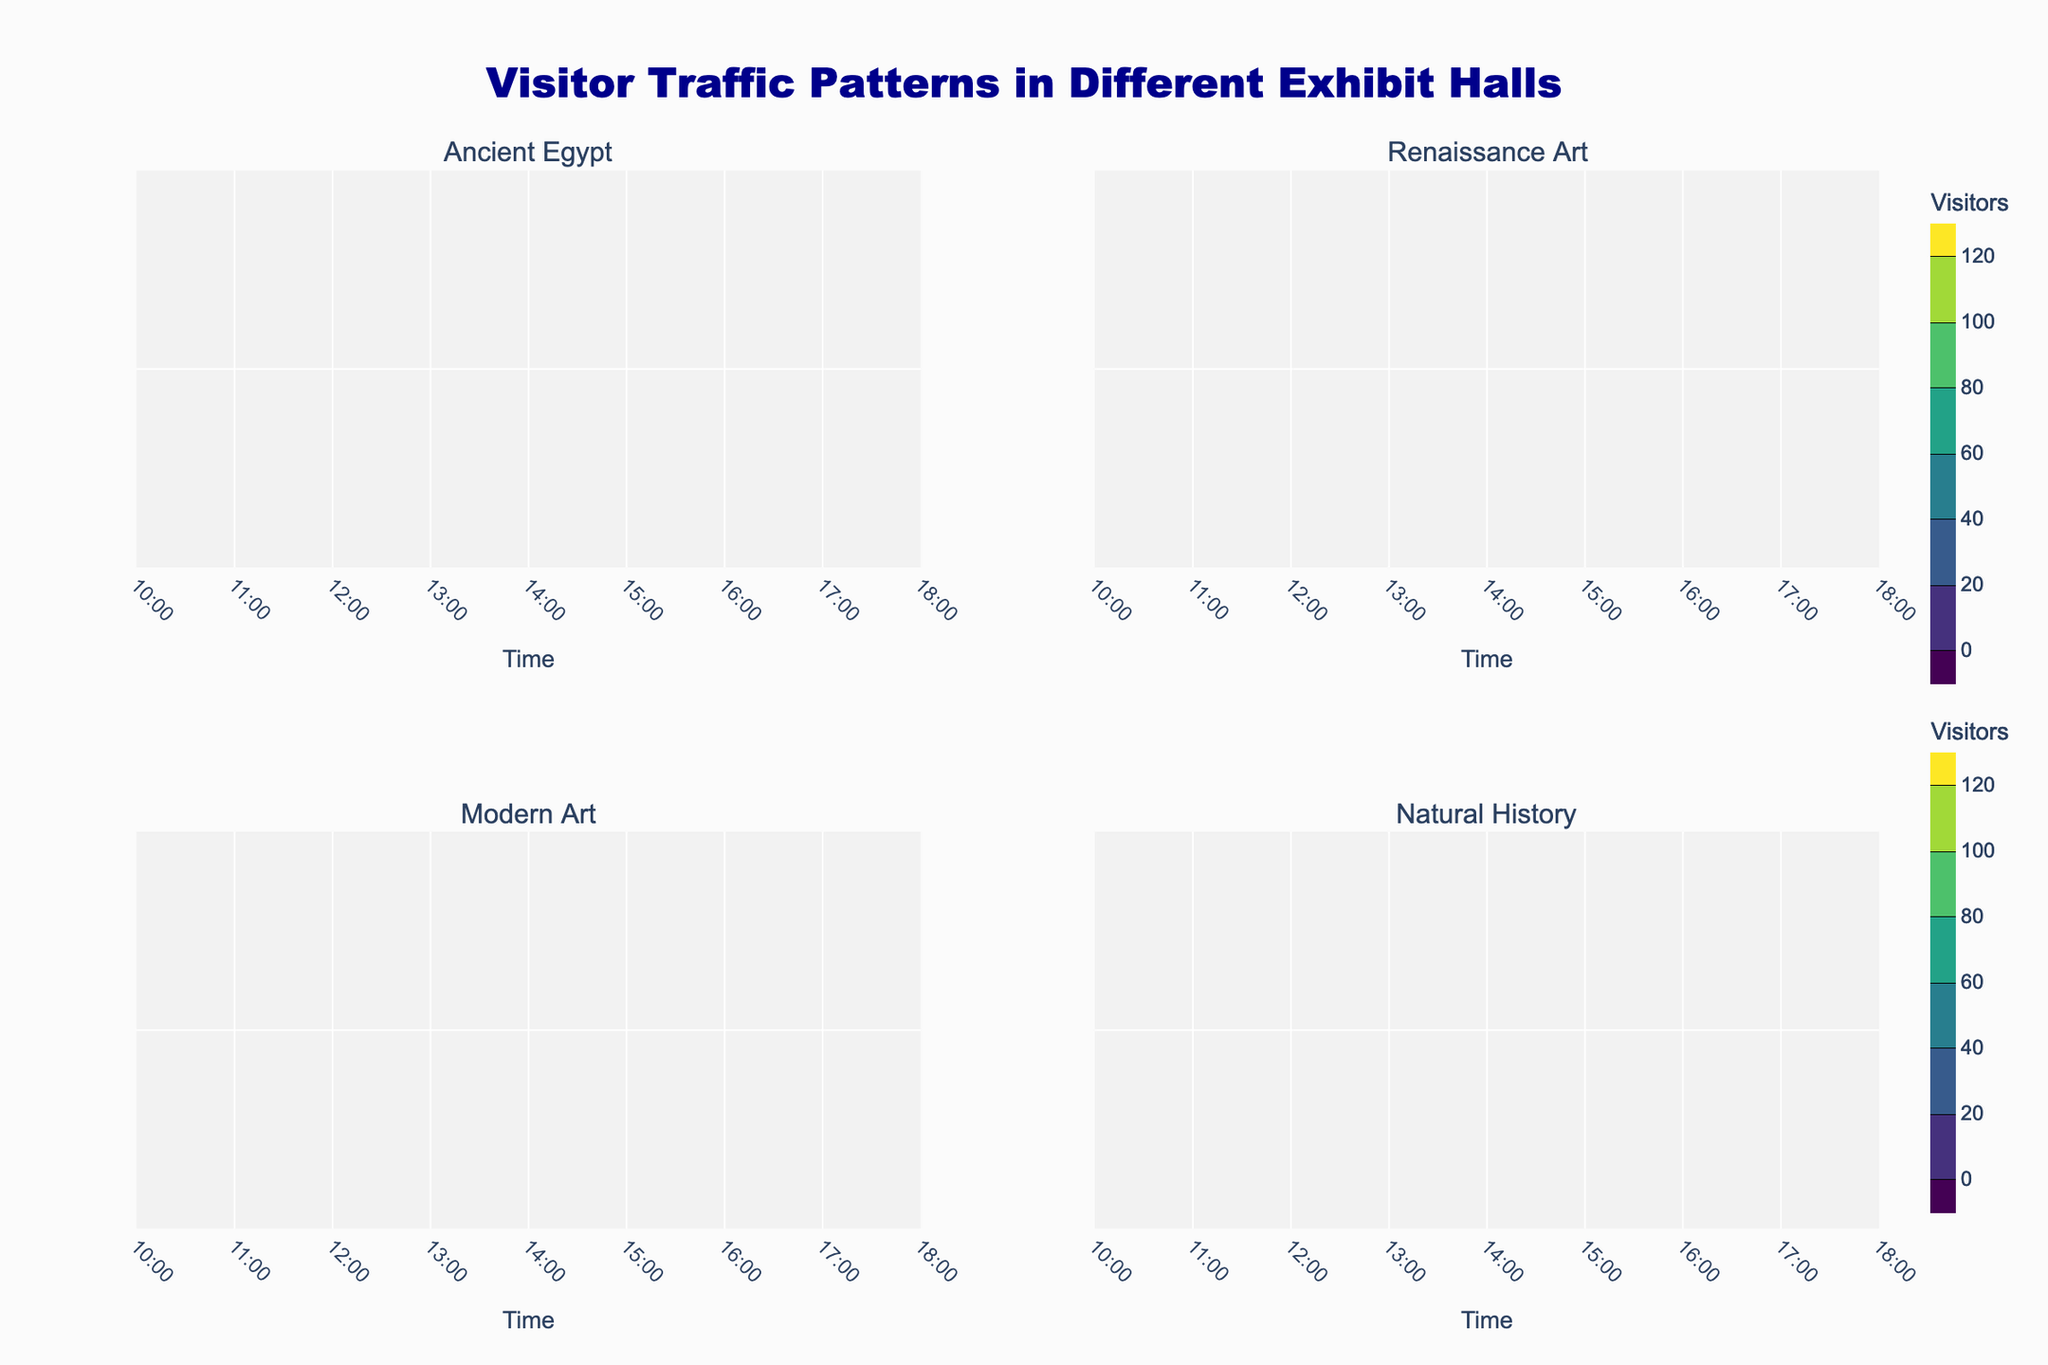What is the title of the figure? The title is displayed prominently at the top of the figure, and it reads "Visitor Traffic Patterns in Different Exhibit Halls."
Answer: Visitor Traffic Patterns in Different Exhibit Halls Which exhibit hall has the highest peak visitor count? By observing the color intensity and the contour levels in each subplot, the Natural History hall shows the highest peak visitor count with 130 visitors around 15:00.
Answer: Natural History hall At what time does the Modern Art hall see the maximum number of visitors? In the subplot for the Modern Art hall, the deepest color intensity and the highest contour label indicate the maximum number of visitors at 16:00 with 120 visitors.
Answer: 16:00 Compare the visitor traffic between 12:00 and 14:00 in the Renaissance Art and Ancient Egypt halls. Which hall experiences a larger increase in visitors? For Renaissance Art, visitors increase from 45 to 75. In Ancient Egypt, they increase from 70 to 90. Renaissance Art sees an increase of 30 visitors, while Ancient Egypt sees an increase of 20 visitors.
Answer: Renaissance Art Identify any time period where visitor traffic is similar across all halls. What time is it? Observe the contour lines and color shades across all subplots, and note if any contours coincide or have similar values regardless of the hall. Around 10:00, the visitor numbers range from 15 to 30, showing the most similarity across all halls.
Answer: 10:00 Determine which hall has the largest variation in visitor traffic throughout the day. Variation in visitor traffic can be assessed by comparing the lowest and highest contour levels in each subplot. The Natural History hall has the largest variation, with visitor counts ranging from 15 to 130.
Answer: Natural History hall How does visitor traffic at 17:00 compare between Modern Art and Renaissance Art halls? The subplot for Modern Art shows 85 visitors at 17:00, while the Renaissance Art hall has 65. Comparing these, Modern Art has more visitors at that time.
Answer: Modern Art Which exhibit hall consistently has the highest visitor traffic between 14:00 and 16:00? From 14:00 to 16:00, the deepest color intensities and highest contour levels are observed in the Natural History and Modern Art halls, with the Natural History reaching the peak visitor count at 15:00 with 130 visitors.
Answer: Natural History hall What is the contour interval size used in the plots? The contour interval size can be determined from the contour levels labeled in the plots. Each contour represents an increment of 20 visitors, as indicated by the levels and the color bar.
Answer: 20 visitors 